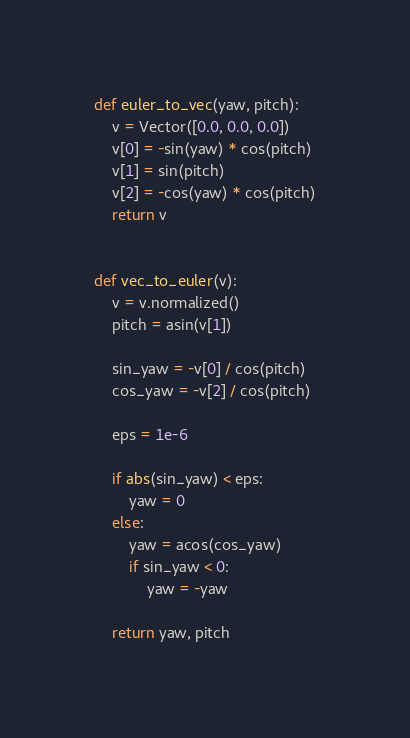Convert code to text. <code><loc_0><loc_0><loc_500><loc_500><_Python_>

def euler_to_vec(yaw, pitch):
    v = Vector([0.0, 0.0, 0.0])
    v[0] = -sin(yaw) * cos(pitch)
    v[1] = sin(pitch)
    v[2] = -cos(yaw) * cos(pitch)
    return v


def vec_to_euler(v):
    v = v.normalized()
    pitch = asin(v[1])

    sin_yaw = -v[0] / cos(pitch)
    cos_yaw = -v[2] / cos(pitch)

    eps = 1e-6

    if abs(sin_yaw) < eps:
        yaw = 0
    else:
        yaw = acos(cos_yaw)
        if sin_yaw < 0:
            yaw = -yaw

    return yaw, pitch
</code> 